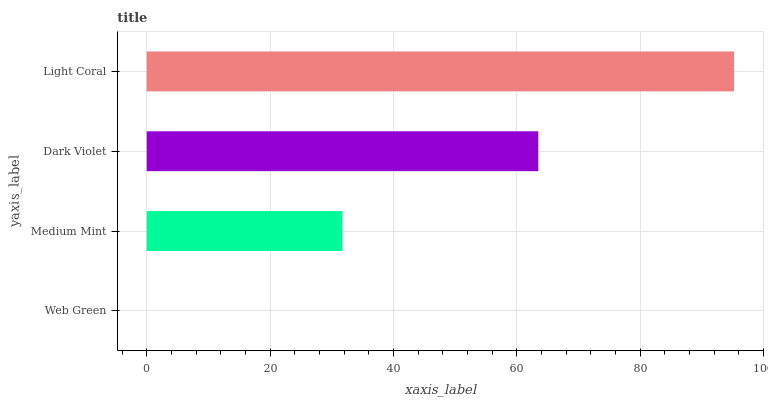Is Web Green the minimum?
Answer yes or no. Yes. Is Light Coral the maximum?
Answer yes or no. Yes. Is Medium Mint the minimum?
Answer yes or no. No. Is Medium Mint the maximum?
Answer yes or no. No. Is Medium Mint greater than Web Green?
Answer yes or no. Yes. Is Web Green less than Medium Mint?
Answer yes or no. Yes. Is Web Green greater than Medium Mint?
Answer yes or no. No. Is Medium Mint less than Web Green?
Answer yes or no. No. Is Dark Violet the high median?
Answer yes or no. Yes. Is Medium Mint the low median?
Answer yes or no. Yes. Is Web Green the high median?
Answer yes or no. No. Is Web Green the low median?
Answer yes or no. No. 